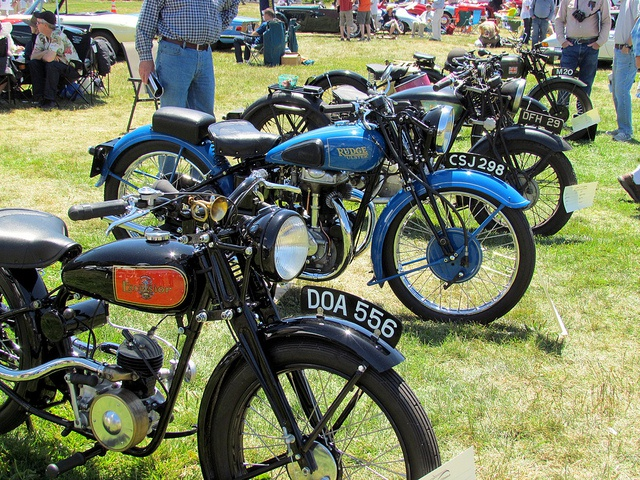Describe the objects in this image and their specific colors. I can see motorcycle in lavender, black, gray, olive, and darkgray tones, motorcycle in lavender, black, gray, navy, and olive tones, people in lavender, black, khaki, gray, and white tones, motorcycle in lavender, black, gray, khaki, and darkgray tones, and people in lavender, blue, and gray tones in this image. 